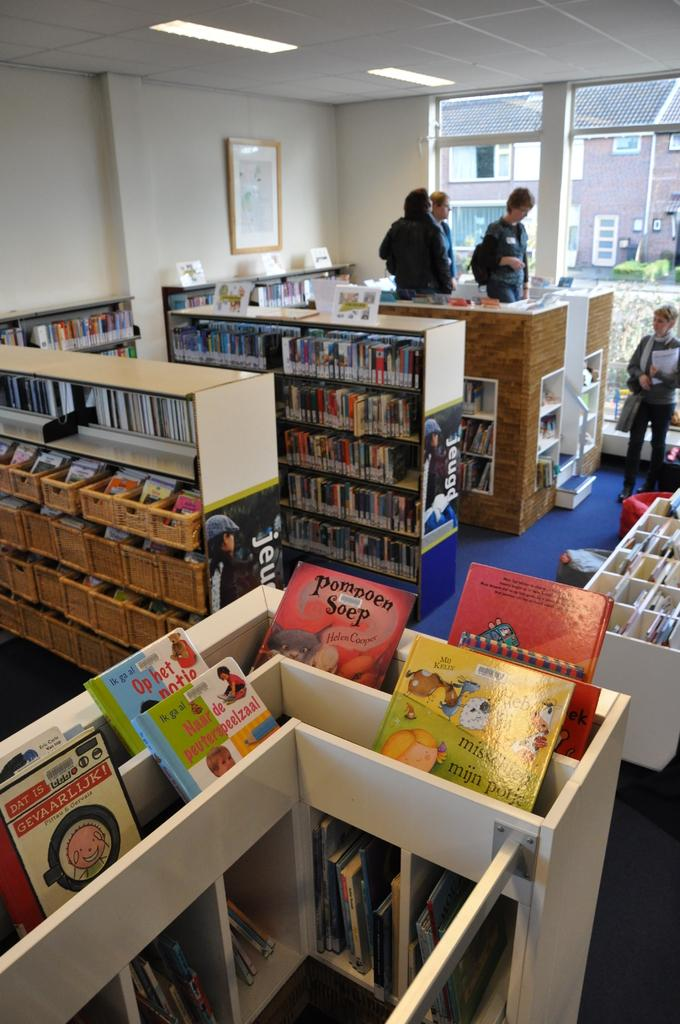<image>
Describe the image concisely. A room full of shelving and children's books with a picture with Jeug printed on the end of some units. 